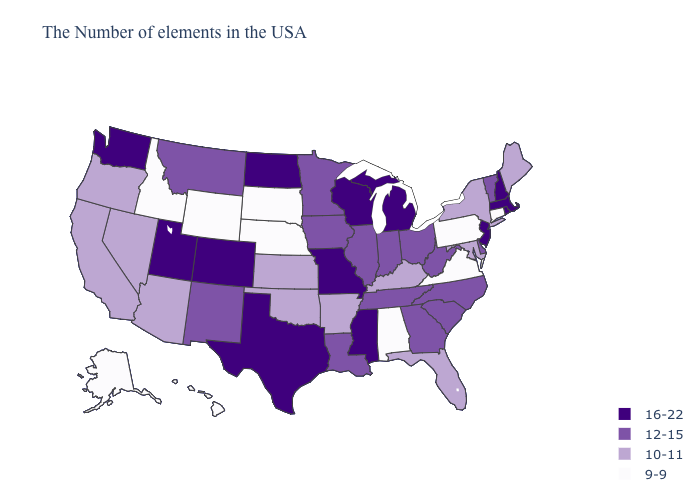What is the value of Illinois?
Keep it brief. 12-15. Name the states that have a value in the range 10-11?
Give a very brief answer. Maine, New York, Maryland, Florida, Kentucky, Arkansas, Kansas, Oklahoma, Arizona, Nevada, California, Oregon. What is the lowest value in states that border California?
Answer briefly. 10-11. Name the states that have a value in the range 10-11?
Keep it brief. Maine, New York, Maryland, Florida, Kentucky, Arkansas, Kansas, Oklahoma, Arizona, Nevada, California, Oregon. What is the highest value in the USA?
Give a very brief answer. 16-22. Which states have the lowest value in the USA?
Quick response, please. Connecticut, Pennsylvania, Virginia, Alabama, Nebraska, South Dakota, Wyoming, Idaho, Alaska, Hawaii. Which states hav the highest value in the South?
Give a very brief answer. Mississippi, Texas. Which states have the highest value in the USA?
Quick response, please. Massachusetts, Rhode Island, New Hampshire, New Jersey, Michigan, Wisconsin, Mississippi, Missouri, Texas, North Dakota, Colorado, Utah, Washington. Does Wyoming have the lowest value in the USA?
Give a very brief answer. Yes. Name the states that have a value in the range 10-11?
Give a very brief answer. Maine, New York, Maryland, Florida, Kentucky, Arkansas, Kansas, Oklahoma, Arizona, Nevada, California, Oregon. Does Idaho have the lowest value in the West?
Concise answer only. Yes. Name the states that have a value in the range 9-9?
Concise answer only. Connecticut, Pennsylvania, Virginia, Alabama, Nebraska, South Dakota, Wyoming, Idaho, Alaska, Hawaii. Does Wyoming have a lower value than Nebraska?
Give a very brief answer. No. What is the highest value in the West ?
Give a very brief answer. 16-22. How many symbols are there in the legend?
Write a very short answer. 4. 